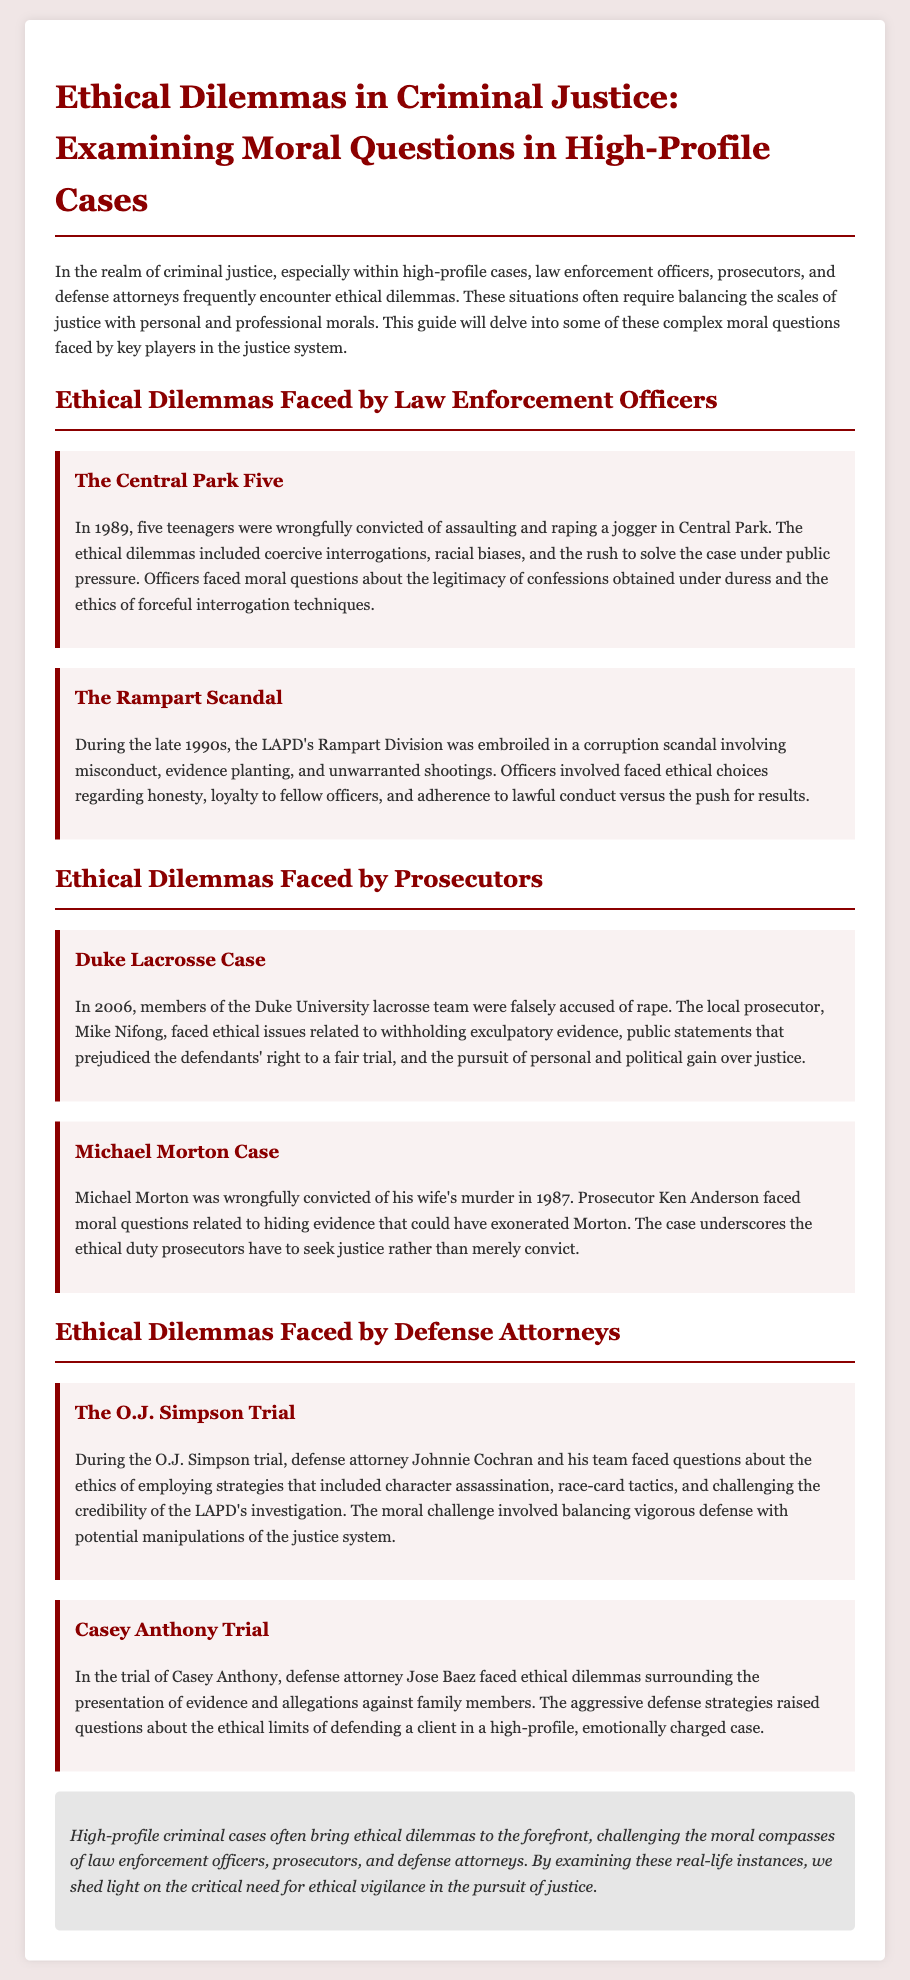What high-profile case involved five teenagers wrongfully convicted? The document mentions "The Central Park Five" as a high-profile case where five teenagers were wrongfully convicted.
Answer: The Central Park Five During which decade did the Rampart Scandal occur? The Rampart Scandal is specified to have taken place during the late 1990s.
Answer: late 1990s Who was the prosecutor in the Duke Lacrosse Case? The document identifies Mike Nifong as the local prosecutor in the Duke Lacrosse Case.
Answer: Mike Nifong What was the ethical issue faced by prosecutor Ken Anderson in the Michael Morton case? The document states that Ken Anderson faced questions related to hiding evidence that could have exonerated Morton.
Answer: hiding evidence What defense strategy was challenged in the O.J. Simpson trial? The document highlights that defense attorney Johnnie Cochran and his team faced issues with "character assassination" as a defense strategy.
Answer: character assassination How did the nature of the Casey Anthony trial create ethical dilemmas for the defense attorney? The document indicates that the aggressive defense strategies raised ethical questions regarding the presentation of evidence and allegations against family members.
Answer: aggressive defense strategies Which ethical dilemma is common among law enforcement officers? The document discusses coercive interrogations as a common ethical dilemma faced by law enforcement officers.
Answer: coercive interrogations What ethical duty do prosecutors have according to the document? The document states that prosecutors have the ethical duty to seek justice rather than merely convict.
Answer: seek justice What color is used for the section headings in this document? The section headings are specified to be in the color #8B0000.
Answer: #8B0000 